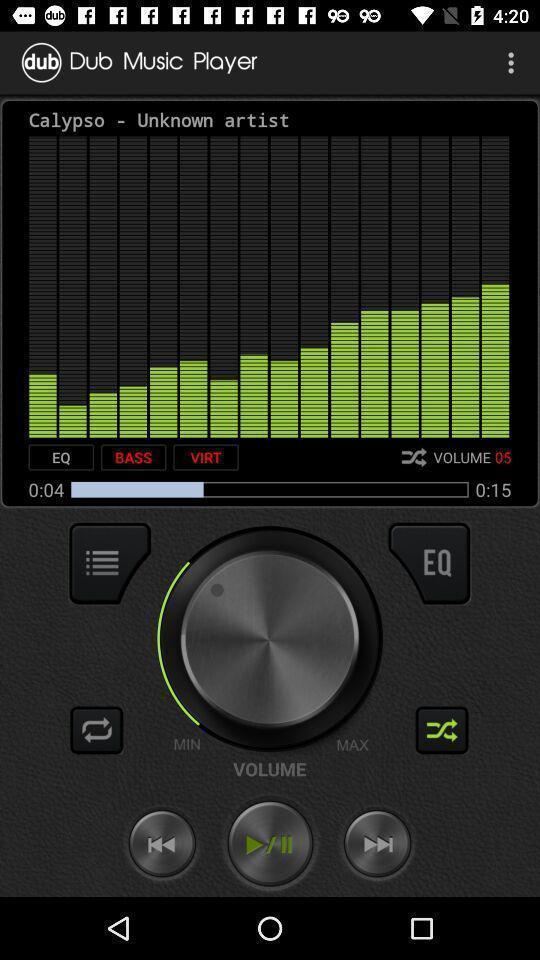Tell me what you see in this picture. Various sound mix options displayed in an audio app. 